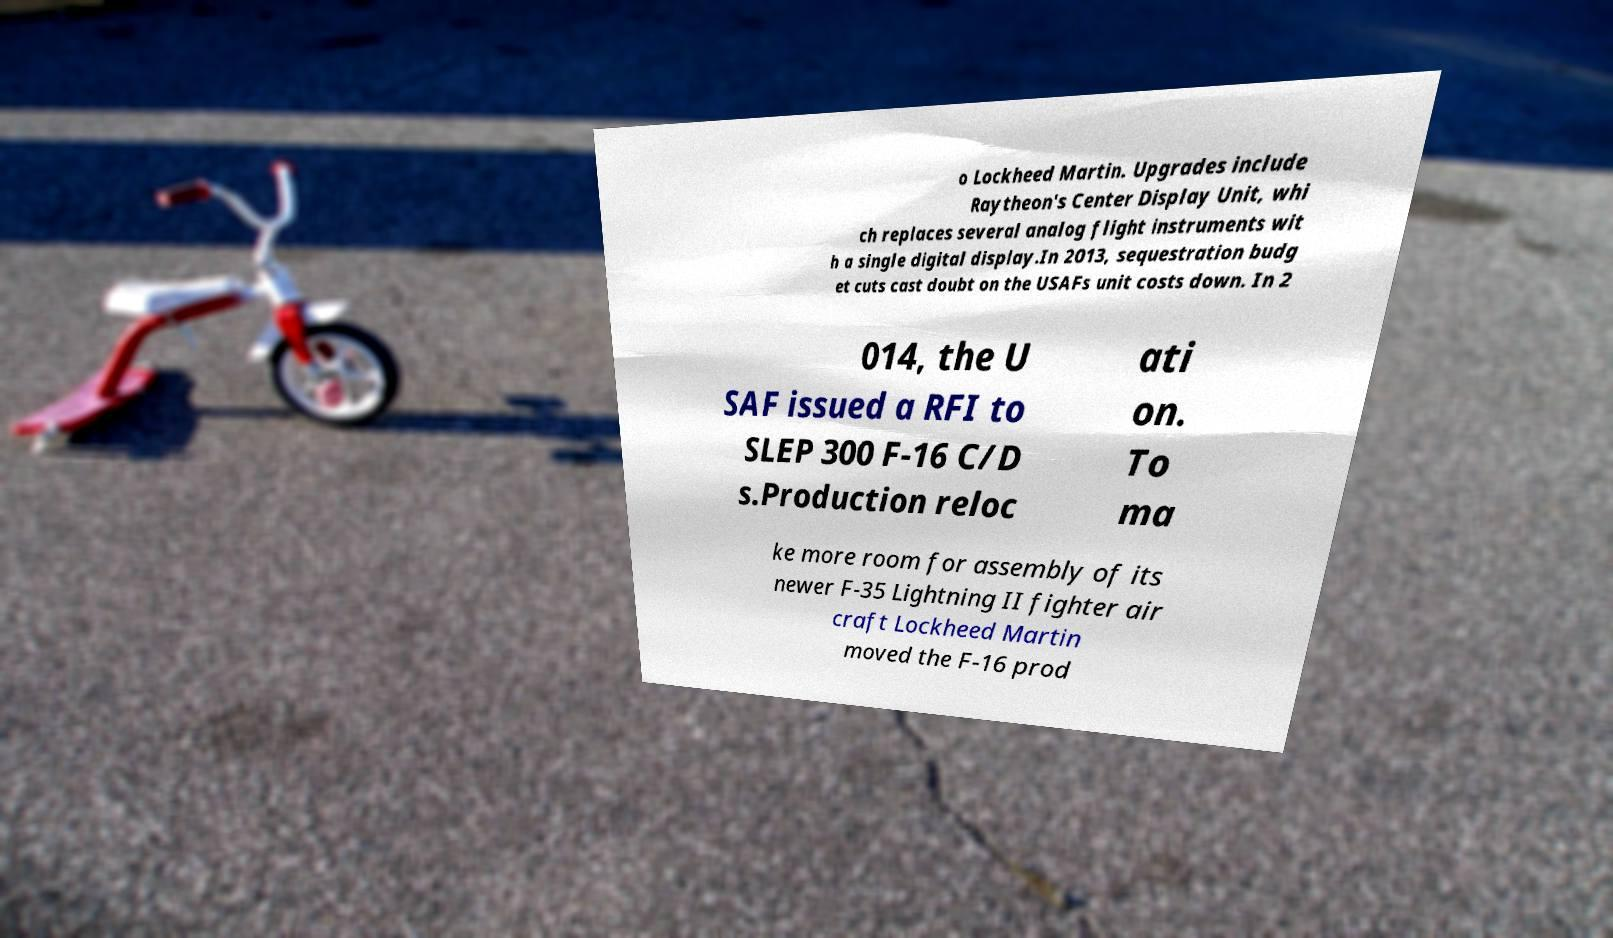Please identify and transcribe the text found in this image. o Lockheed Martin. Upgrades include Raytheon's Center Display Unit, whi ch replaces several analog flight instruments wit h a single digital display.In 2013, sequestration budg et cuts cast doubt on the USAFs unit costs down. In 2 014, the U SAF issued a RFI to SLEP 300 F-16 C/D s.Production reloc ati on. To ma ke more room for assembly of its newer F-35 Lightning II fighter air craft Lockheed Martin moved the F-16 prod 